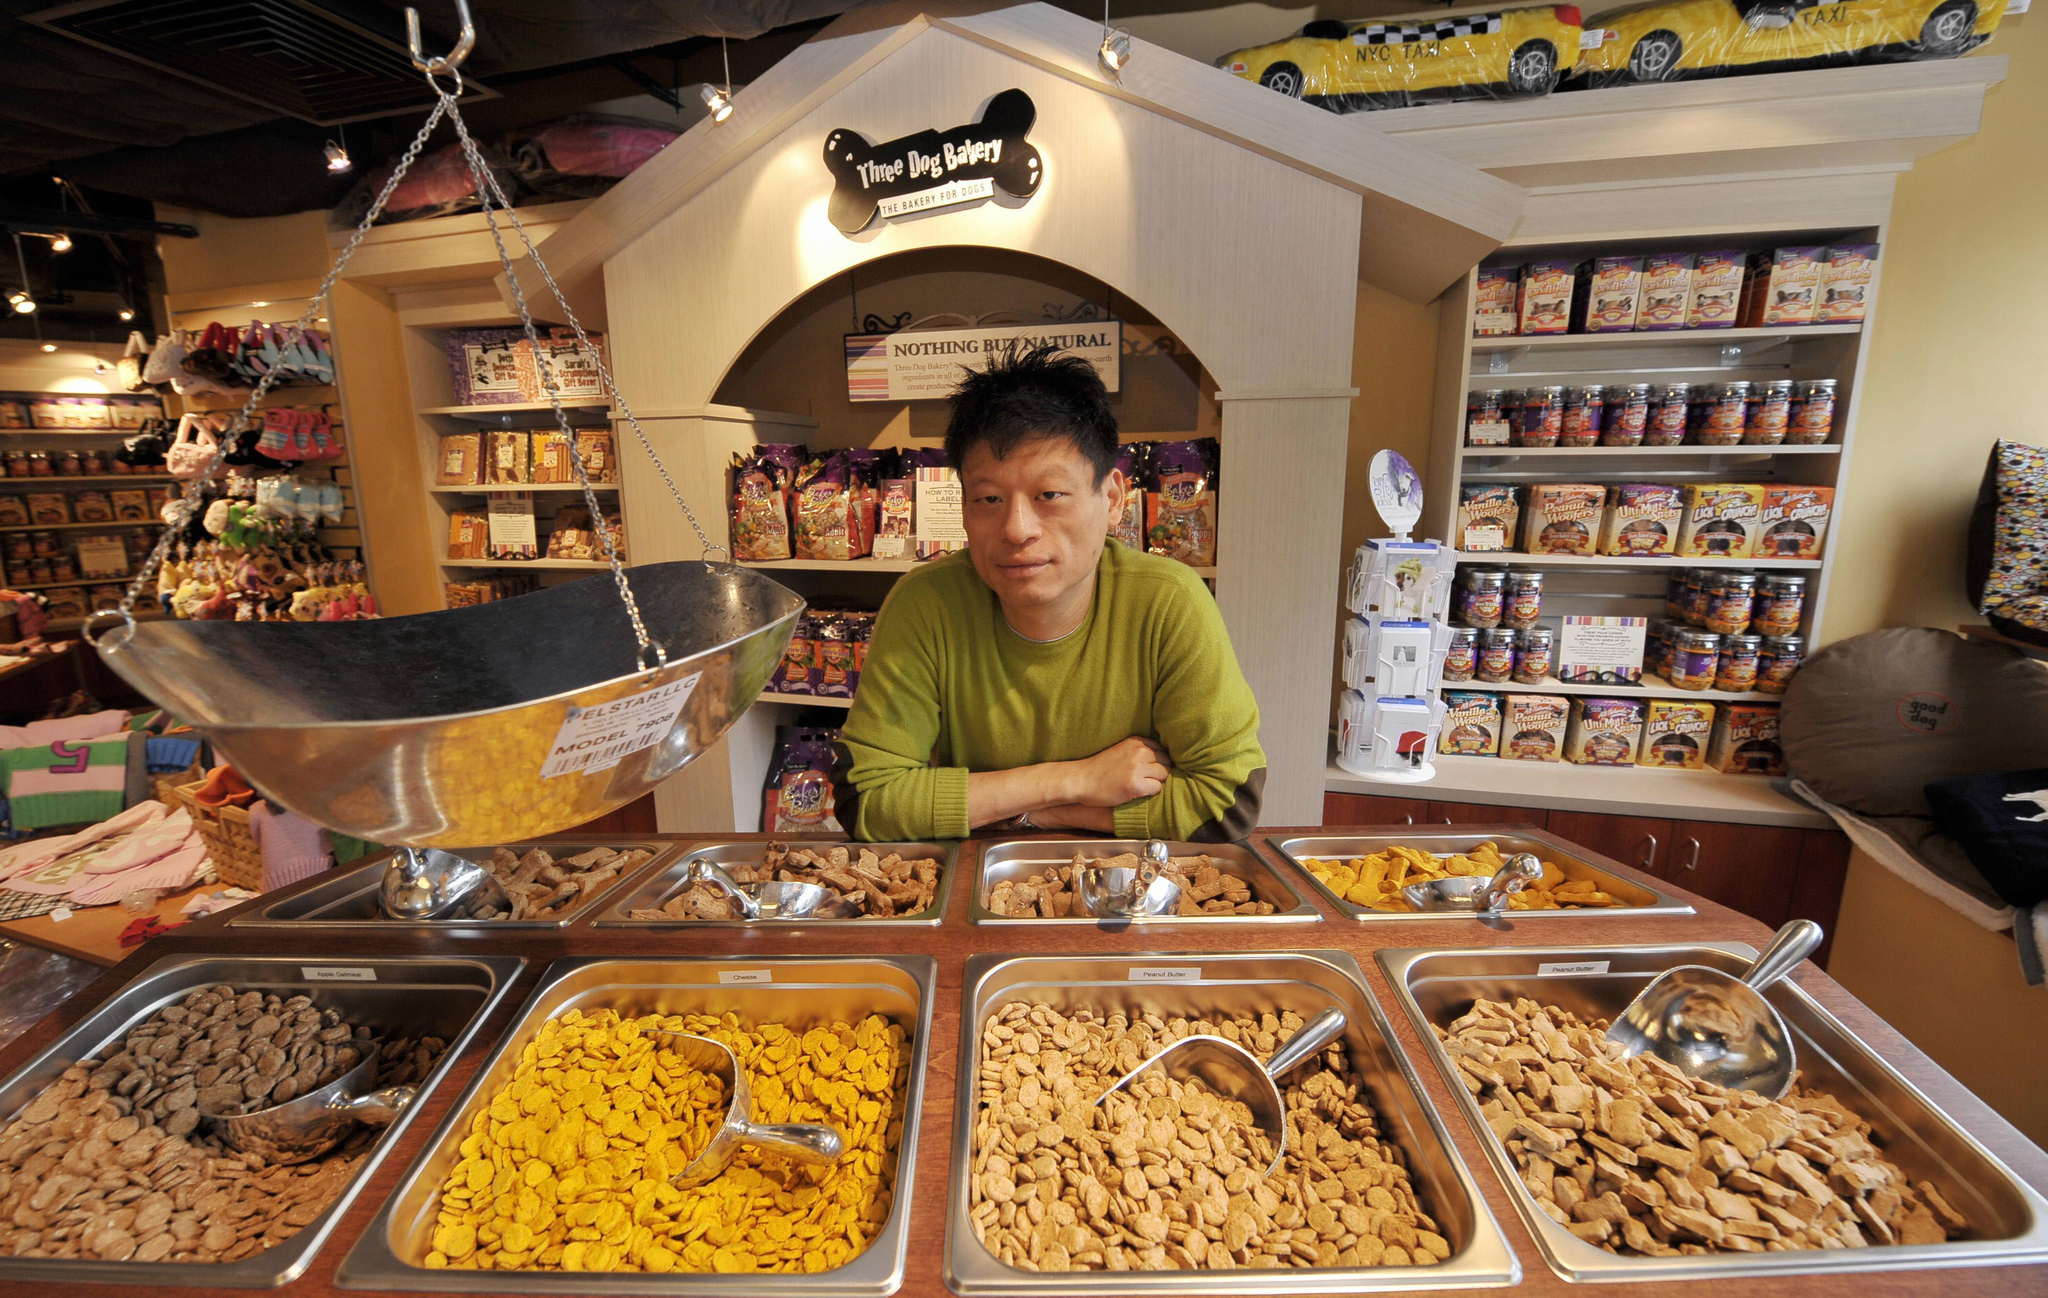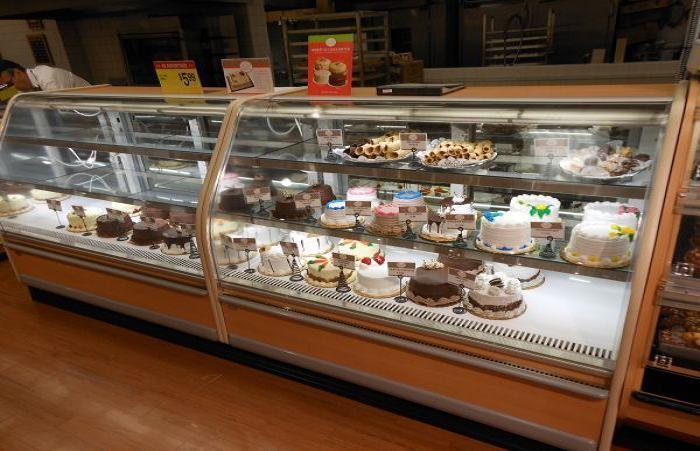The first image is the image on the left, the second image is the image on the right. For the images shown, is this caption "A real dog is standing on all fours in front of a display case in one image." true? Answer yes or no. No. The first image is the image on the left, the second image is the image on the right. Considering the images on both sides, is "In one of the images, a dog is looking at the cakes." valid? Answer yes or no. No. 